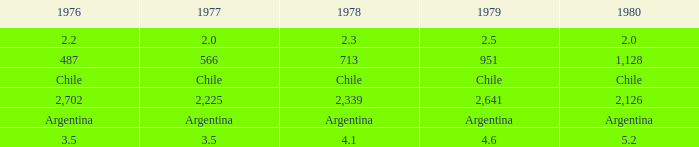What is 1980 when 1979 is 951? 1128.0. 